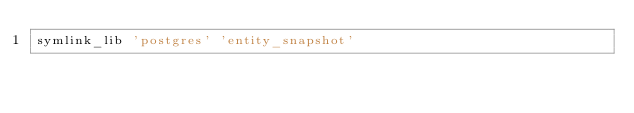<code> <loc_0><loc_0><loc_500><loc_500><_Bash_>symlink_lib 'postgres' 'entity_snapshot'
</code> 